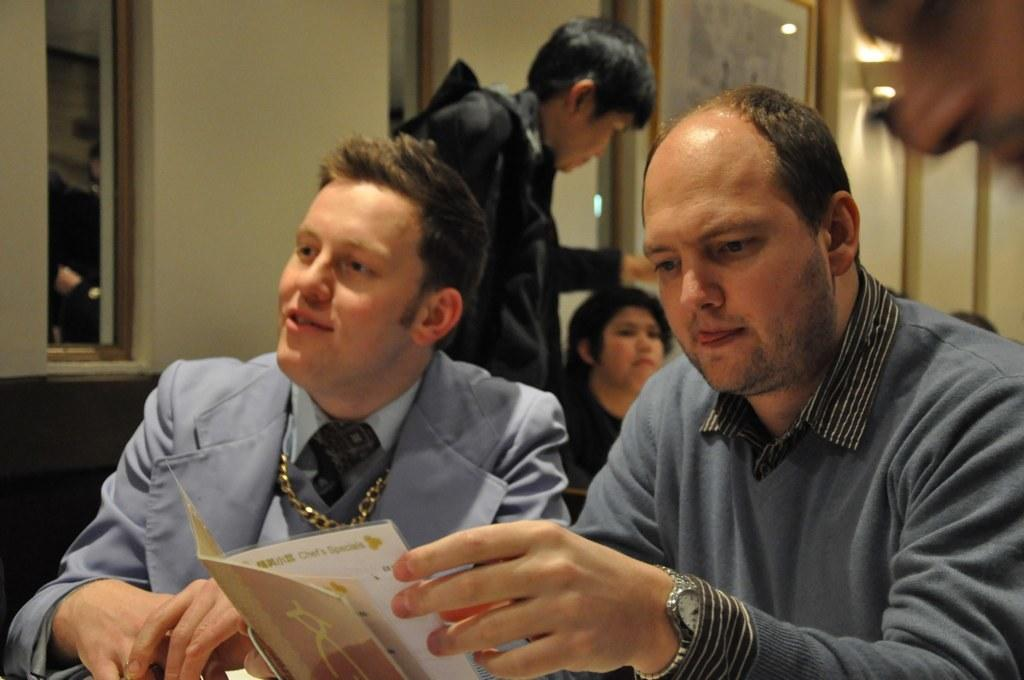How many men are in the foreground of the image? There are two men in the foreground of the image. What else can be seen in the background of the image? There are other people and a wall in the background of the image. What is attached to the wall in the image? There is a photo frame attached to the wall. What type of friction is being generated by the needle in the image? There is no needle present in the image, so friction cannot be generated by a needle. 